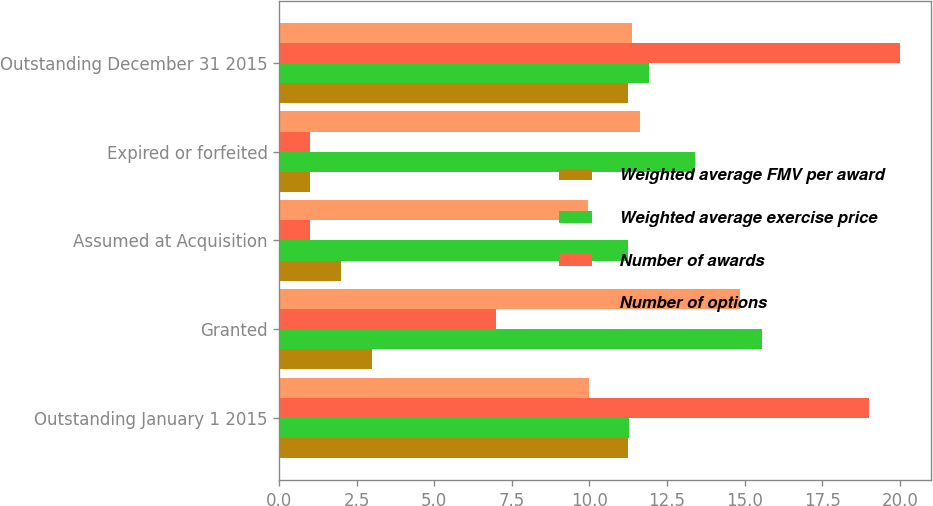Convert chart. <chart><loc_0><loc_0><loc_500><loc_500><stacked_bar_chart><ecel><fcel>Outstanding January 1 2015<fcel>Granted<fcel>Assumed at Acquisition<fcel>Expired or forfeited<fcel>Outstanding December 31 2015<nl><fcel>Weighted average FMV per award<fcel>11.25<fcel>3<fcel>2<fcel>1<fcel>11.25<nl><fcel>Weighted average exercise price<fcel>11.26<fcel>15.55<fcel>11.24<fcel>13.39<fcel>11.91<nl><fcel>Number of awards<fcel>19<fcel>7<fcel>1<fcel>1<fcel>20<nl><fcel>Number of options<fcel>9.98<fcel>14.85<fcel>9.96<fcel>11.64<fcel>11.38<nl></chart> 